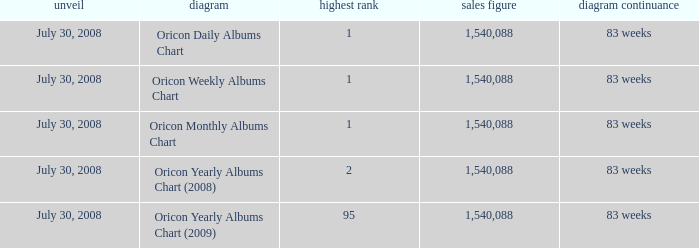Could you help me parse every detail presented in this table? {'header': ['unveil', 'diagram', 'highest rank', 'sales figure', 'diagram continuance'], 'rows': [['July 30, 2008', 'Oricon Daily Albums Chart', '1', '1,540,088', '83 weeks'], ['July 30, 2008', 'Oricon Weekly Albums Chart', '1', '1,540,088', '83 weeks'], ['July 30, 2008', 'Oricon Monthly Albums Chart', '1', '1,540,088', '83 weeks'], ['July 30, 2008', 'Oricon Yearly Albums Chart (2008)', '2', '1,540,088', '83 weeks'], ['July 30, 2008', 'Oricon Yearly Albums Chart (2009)', '95', '1,540,088', '83 weeks']]} Which Sales Total has a Chart of oricon monthly albums chart? 1540088.0. 